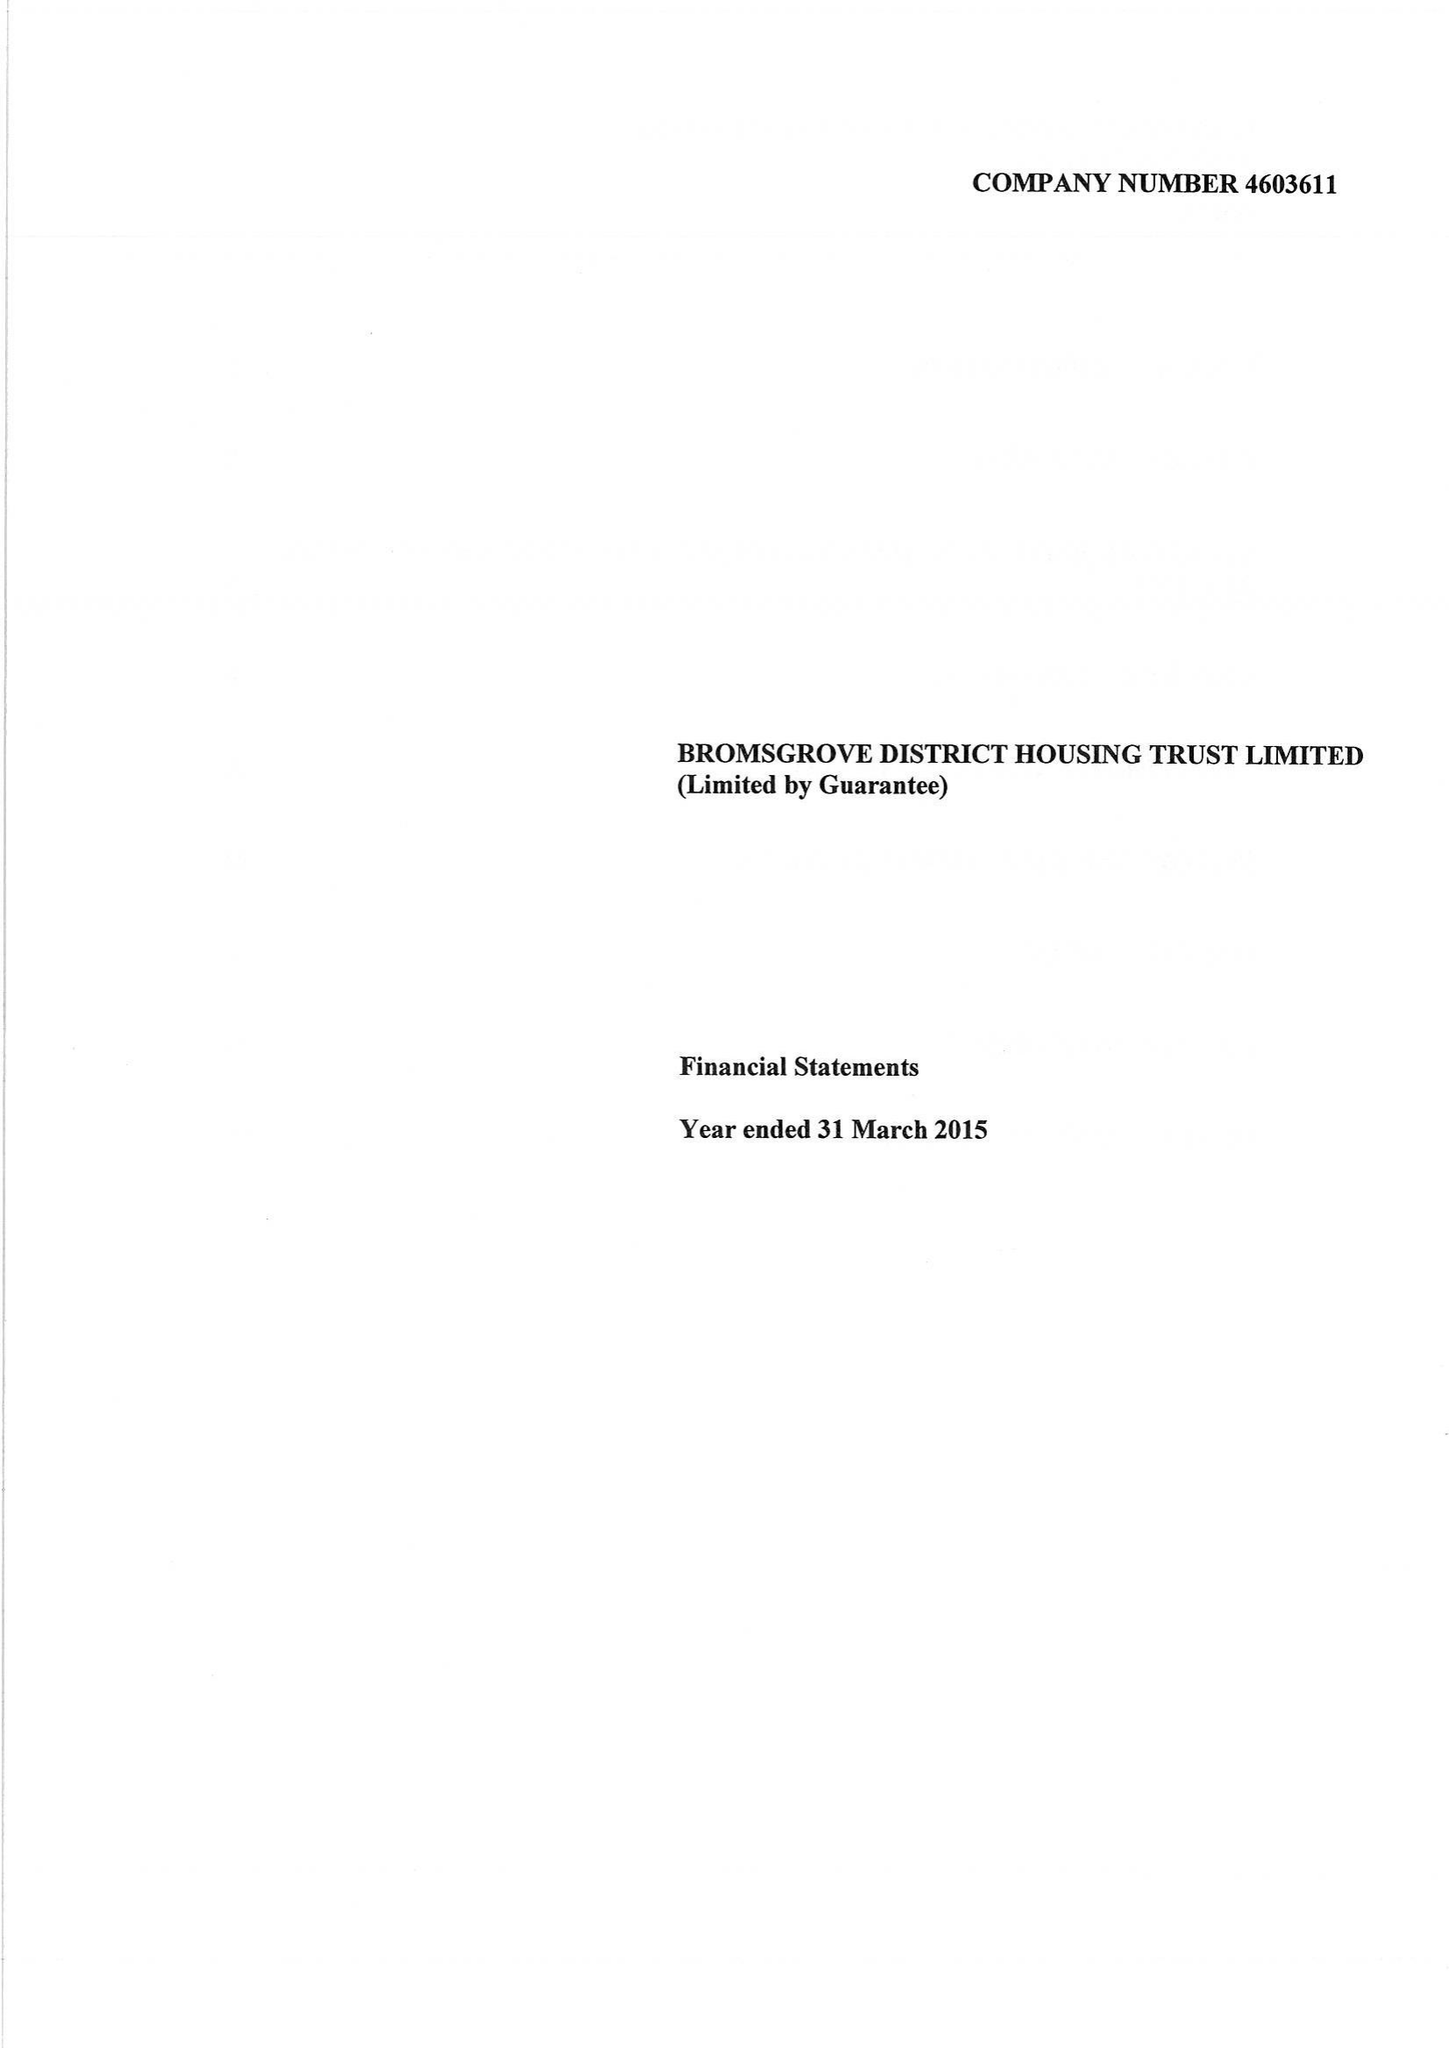What is the value for the charity_number?
Answer the question using a single word or phrase. 1111423 